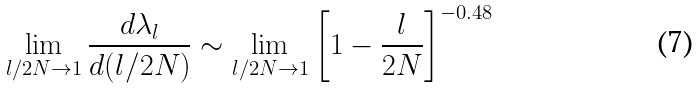<formula> <loc_0><loc_0><loc_500><loc_500>\lim _ { l / 2 N \to 1 } \frac { d \lambda _ { l } } { d ( l / 2 N ) } \sim \lim _ { l / 2 N \to 1 } \left [ 1 - \frac { l } { 2 N } \right ] ^ { - 0 . 4 8 }</formula> 